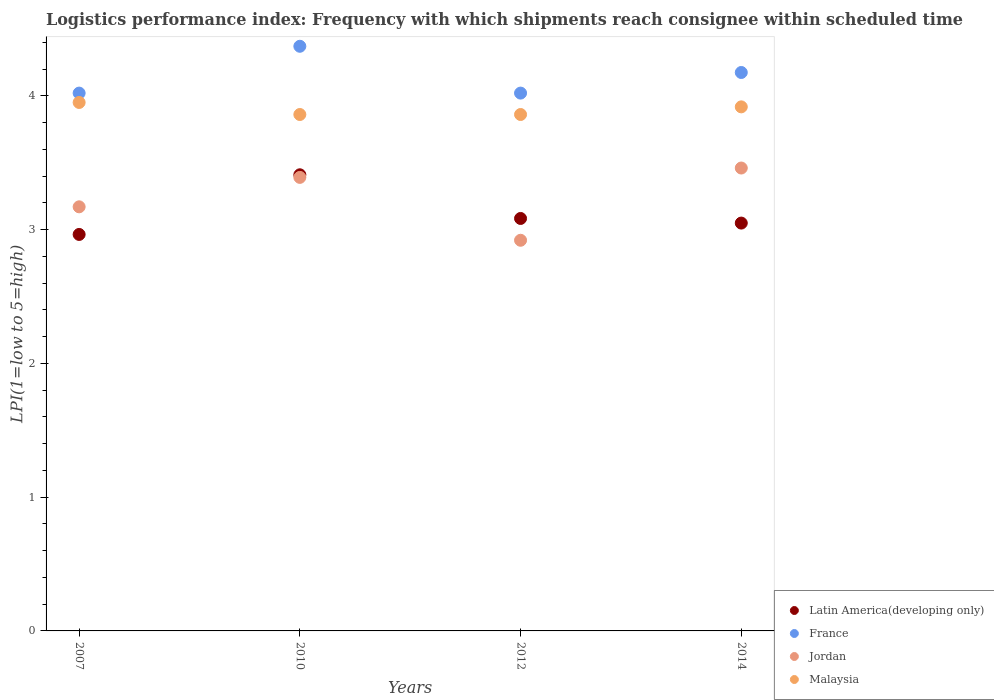How many different coloured dotlines are there?
Your response must be concise. 4. Is the number of dotlines equal to the number of legend labels?
Make the answer very short. Yes. What is the logistics performance index in Latin America(developing only) in 2007?
Provide a short and direct response. 2.96. Across all years, what is the maximum logistics performance index in Latin America(developing only)?
Offer a terse response. 3.41. Across all years, what is the minimum logistics performance index in Latin America(developing only)?
Your answer should be very brief. 2.96. What is the total logistics performance index in France in the graph?
Offer a very short reply. 16.58. What is the difference between the logistics performance index in Latin America(developing only) in 2014 and the logistics performance index in Malaysia in 2010?
Your answer should be compact. -0.81. What is the average logistics performance index in Latin America(developing only) per year?
Provide a short and direct response. 3.13. In the year 2014, what is the difference between the logistics performance index in Latin America(developing only) and logistics performance index in Malaysia?
Your answer should be very brief. -0.87. In how many years, is the logistics performance index in Latin America(developing only) greater than 1.6?
Your response must be concise. 4. What is the ratio of the logistics performance index in France in 2010 to that in 2012?
Ensure brevity in your answer.  1.09. Is the logistics performance index in Malaysia in 2010 less than that in 2012?
Offer a very short reply. No. Is the difference between the logistics performance index in Latin America(developing only) in 2007 and 2010 greater than the difference between the logistics performance index in Malaysia in 2007 and 2010?
Your answer should be compact. No. What is the difference between the highest and the second highest logistics performance index in Jordan?
Offer a very short reply. 0.07. What is the difference between the highest and the lowest logistics performance index in Latin America(developing only)?
Provide a short and direct response. 0.45. In how many years, is the logistics performance index in Malaysia greater than the average logistics performance index in Malaysia taken over all years?
Ensure brevity in your answer.  2. Is it the case that in every year, the sum of the logistics performance index in Malaysia and logistics performance index in Latin America(developing only)  is greater than the logistics performance index in Jordan?
Your answer should be very brief. Yes. Is the logistics performance index in France strictly greater than the logistics performance index in Latin America(developing only) over the years?
Give a very brief answer. Yes. How many dotlines are there?
Keep it short and to the point. 4. Are the values on the major ticks of Y-axis written in scientific E-notation?
Your answer should be very brief. No. Does the graph contain any zero values?
Make the answer very short. No. Where does the legend appear in the graph?
Offer a terse response. Bottom right. How many legend labels are there?
Ensure brevity in your answer.  4. What is the title of the graph?
Give a very brief answer. Logistics performance index: Frequency with which shipments reach consignee within scheduled time. What is the label or title of the Y-axis?
Give a very brief answer. LPI(1=low to 5=high). What is the LPI(1=low to 5=high) in Latin America(developing only) in 2007?
Your answer should be compact. 2.96. What is the LPI(1=low to 5=high) in France in 2007?
Your answer should be very brief. 4.02. What is the LPI(1=low to 5=high) of Jordan in 2007?
Keep it short and to the point. 3.17. What is the LPI(1=low to 5=high) in Malaysia in 2007?
Give a very brief answer. 3.95. What is the LPI(1=low to 5=high) in Latin America(developing only) in 2010?
Make the answer very short. 3.41. What is the LPI(1=low to 5=high) in France in 2010?
Your response must be concise. 4.37. What is the LPI(1=low to 5=high) of Jordan in 2010?
Give a very brief answer. 3.39. What is the LPI(1=low to 5=high) of Malaysia in 2010?
Keep it short and to the point. 3.86. What is the LPI(1=low to 5=high) of Latin America(developing only) in 2012?
Make the answer very short. 3.08. What is the LPI(1=low to 5=high) of France in 2012?
Keep it short and to the point. 4.02. What is the LPI(1=low to 5=high) of Jordan in 2012?
Make the answer very short. 2.92. What is the LPI(1=low to 5=high) of Malaysia in 2012?
Provide a short and direct response. 3.86. What is the LPI(1=low to 5=high) in Latin America(developing only) in 2014?
Ensure brevity in your answer.  3.05. What is the LPI(1=low to 5=high) of France in 2014?
Your answer should be very brief. 4.17. What is the LPI(1=low to 5=high) of Jordan in 2014?
Give a very brief answer. 3.46. What is the LPI(1=low to 5=high) of Malaysia in 2014?
Give a very brief answer. 3.92. Across all years, what is the maximum LPI(1=low to 5=high) of Latin America(developing only)?
Your response must be concise. 3.41. Across all years, what is the maximum LPI(1=low to 5=high) of France?
Provide a short and direct response. 4.37. Across all years, what is the maximum LPI(1=low to 5=high) in Jordan?
Your answer should be very brief. 3.46. Across all years, what is the maximum LPI(1=low to 5=high) of Malaysia?
Your answer should be very brief. 3.95. Across all years, what is the minimum LPI(1=low to 5=high) of Latin America(developing only)?
Give a very brief answer. 2.96. Across all years, what is the minimum LPI(1=low to 5=high) in France?
Your answer should be very brief. 4.02. Across all years, what is the minimum LPI(1=low to 5=high) of Jordan?
Your answer should be compact. 2.92. Across all years, what is the minimum LPI(1=low to 5=high) in Malaysia?
Your answer should be very brief. 3.86. What is the total LPI(1=low to 5=high) of Latin America(developing only) in the graph?
Offer a terse response. 12.5. What is the total LPI(1=low to 5=high) in France in the graph?
Make the answer very short. 16.58. What is the total LPI(1=low to 5=high) of Jordan in the graph?
Your answer should be compact. 12.94. What is the total LPI(1=low to 5=high) of Malaysia in the graph?
Your response must be concise. 15.59. What is the difference between the LPI(1=low to 5=high) in Latin America(developing only) in 2007 and that in 2010?
Make the answer very short. -0.45. What is the difference between the LPI(1=low to 5=high) in France in 2007 and that in 2010?
Ensure brevity in your answer.  -0.35. What is the difference between the LPI(1=low to 5=high) in Jordan in 2007 and that in 2010?
Give a very brief answer. -0.22. What is the difference between the LPI(1=low to 5=high) of Malaysia in 2007 and that in 2010?
Make the answer very short. 0.09. What is the difference between the LPI(1=low to 5=high) of Latin America(developing only) in 2007 and that in 2012?
Your answer should be very brief. -0.12. What is the difference between the LPI(1=low to 5=high) of France in 2007 and that in 2012?
Provide a short and direct response. 0. What is the difference between the LPI(1=low to 5=high) of Jordan in 2007 and that in 2012?
Keep it short and to the point. 0.25. What is the difference between the LPI(1=low to 5=high) in Malaysia in 2007 and that in 2012?
Provide a short and direct response. 0.09. What is the difference between the LPI(1=low to 5=high) of Latin America(developing only) in 2007 and that in 2014?
Make the answer very short. -0.08. What is the difference between the LPI(1=low to 5=high) of France in 2007 and that in 2014?
Give a very brief answer. -0.15. What is the difference between the LPI(1=low to 5=high) in Jordan in 2007 and that in 2014?
Keep it short and to the point. -0.29. What is the difference between the LPI(1=low to 5=high) of Malaysia in 2007 and that in 2014?
Make the answer very short. 0.03. What is the difference between the LPI(1=low to 5=high) of Latin America(developing only) in 2010 and that in 2012?
Ensure brevity in your answer.  0.33. What is the difference between the LPI(1=low to 5=high) of Jordan in 2010 and that in 2012?
Give a very brief answer. 0.47. What is the difference between the LPI(1=low to 5=high) of Malaysia in 2010 and that in 2012?
Your answer should be very brief. 0. What is the difference between the LPI(1=low to 5=high) in Latin America(developing only) in 2010 and that in 2014?
Ensure brevity in your answer.  0.36. What is the difference between the LPI(1=low to 5=high) of France in 2010 and that in 2014?
Ensure brevity in your answer.  0.2. What is the difference between the LPI(1=low to 5=high) in Jordan in 2010 and that in 2014?
Provide a short and direct response. -0.07. What is the difference between the LPI(1=low to 5=high) in Malaysia in 2010 and that in 2014?
Your answer should be very brief. -0.06. What is the difference between the LPI(1=low to 5=high) of Latin America(developing only) in 2012 and that in 2014?
Provide a short and direct response. 0.03. What is the difference between the LPI(1=low to 5=high) in France in 2012 and that in 2014?
Your answer should be very brief. -0.15. What is the difference between the LPI(1=low to 5=high) of Jordan in 2012 and that in 2014?
Offer a terse response. -0.54. What is the difference between the LPI(1=low to 5=high) of Malaysia in 2012 and that in 2014?
Your answer should be very brief. -0.06. What is the difference between the LPI(1=low to 5=high) of Latin America(developing only) in 2007 and the LPI(1=low to 5=high) of France in 2010?
Your answer should be very brief. -1.41. What is the difference between the LPI(1=low to 5=high) of Latin America(developing only) in 2007 and the LPI(1=low to 5=high) of Jordan in 2010?
Keep it short and to the point. -0.43. What is the difference between the LPI(1=low to 5=high) of Latin America(developing only) in 2007 and the LPI(1=low to 5=high) of Malaysia in 2010?
Your answer should be compact. -0.9. What is the difference between the LPI(1=low to 5=high) of France in 2007 and the LPI(1=low to 5=high) of Jordan in 2010?
Make the answer very short. 0.63. What is the difference between the LPI(1=low to 5=high) in France in 2007 and the LPI(1=low to 5=high) in Malaysia in 2010?
Keep it short and to the point. 0.16. What is the difference between the LPI(1=low to 5=high) in Jordan in 2007 and the LPI(1=low to 5=high) in Malaysia in 2010?
Your answer should be compact. -0.69. What is the difference between the LPI(1=low to 5=high) in Latin America(developing only) in 2007 and the LPI(1=low to 5=high) in France in 2012?
Provide a succinct answer. -1.06. What is the difference between the LPI(1=low to 5=high) of Latin America(developing only) in 2007 and the LPI(1=low to 5=high) of Jordan in 2012?
Provide a succinct answer. 0.04. What is the difference between the LPI(1=low to 5=high) of Latin America(developing only) in 2007 and the LPI(1=low to 5=high) of Malaysia in 2012?
Provide a succinct answer. -0.9. What is the difference between the LPI(1=low to 5=high) of France in 2007 and the LPI(1=low to 5=high) of Jordan in 2012?
Ensure brevity in your answer.  1.1. What is the difference between the LPI(1=low to 5=high) of France in 2007 and the LPI(1=low to 5=high) of Malaysia in 2012?
Your answer should be compact. 0.16. What is the difference between the LPI(1=low to 5=high) of Jordan in 2007 and the LPI(1=low to 5=high) of Malaysia in 2012?
Your answer should be compact. -0.69. What is the difference between the LPI(1=low to 5=high) in Latin America(developing only) in 2007 and the LPI(1=low to 5=high) in France in 2014?
Your response must be concise. -1.21. What is the difference between the LPI(1=low to 5=high) in Latin America(developing only) in 2007 and the LPI(1=low to 5=high) in Jordan in 2014?
Make the answer very short. -0.5. What is the difference between the LPI(1=low to 5=high) in Latin America(developing only) in 2007 and the LPI(1=low to 5=high) in Malaysia in 2014?
Ensure brevity in your answer.  -0.95. What is the difference between the LPI(1=low to 5=high) of France in 2007 and the LPI(1=low to 5=high) of Jordan in 2014?
Your answer should be compact. 0.56. What is the difference between the LPI(1=low to 5=high) in France in 2007 and the LPI(1=low to 5=high) in Malaysia in 2014?
Offer a very short reply. 0.1. What is the difference between the LPI(1=low to 5=high) in Jordan in 2007 and the LPI(1=low to 5=high) in Malaysia in 2014?
Your answer should be compact. -0.75. What is the difference between the LPI(1=low to 5=high) in Latin America(developing only) in 2010 and the LPI(1=low to 5=high) in France in 2012?
Provide a succinct answer. -0.61. What is the difference between the LPI(1=low to 5=high) in Latin America(developing only) in 2010 and the LPI(1=low to 5=high) in Jordan in 2012?
Give a very brief answer. 0.49. What is the difference between the LPI(1=low to 5=high) of Latin America(developing only) in 2010 and the LPI(1=low to 5=high) of Malaysia in 2012?
Give a very brief answer. -0.45. What is the difference between the LPI(1=low to 5=high) of France in 2010 and the LPI(1=low to 5=high) of Jordan in 2012?
Provide a short and direct response. 1.45. What is the difference between the LPI(1=low to 5=high) in France in 2010 and the LPI(1=low to 5=high) in Malaysia in 2012?
Your answer should be compact. 0.51. What is the difference between the LPI(1=low to 5=high) in Jordan in 2010 and the LPI(1=low to 5=high) in Malaysia in 2012?
Keep it short and to the point. -0.47. What is the difference between the LPI(1=low to 5=high) in Latin America(developing only) in 2010 and the LPI(1=low to 5=high) in France in 2014?
Offer a terse response. -0.76. What is the difference between the LPI(1=low to 5=high) in Latin America(developing only) in 2010 and the LPI(1=low to 5=high) in Jordan in 2014?
Provide a short and direct response. -0.05. What is the difference between the LPI(1=low to 5=high) of Latin America(developing only) in 2010 and the LPI(1=low to 5=high) of Malaysia in 2014?
Make the answer very short. -0.51. What is the difference between the LPI(1=low to 5=high) in France in 2010 and the LPI(1=low to 5=high) in Jordan in 2014?
Keep it short and to the point. 0.91. What is the difference between the LPI(1=low to 5=high) in France in 2010 and the LPI(1=low to 5=high) in Malaysia in 2014?
Your answer should be very brief. 0.45. What is the difference between the LPI(1=low to 5=high) of Jordan in 2010 and the LPI(1=low to 5=high) of Malaysia in 2014?
Offer a terse response. -0.53. What is the difference between the LPI(1=low to 5=high) in Latin America(developing only) in 2012 and the LPI(1=low to 5=high) in France in 2014?
Give a very brief answer. -1.09. What is the difference between the LPI(1=low to 5=high) in Latin America(developing only) in 2012 and the LPI(1=low to 5=high) in Jordan in 2014?
Make the answer very short. -0.38. What is the difference between the LPI(1=low to 5=high) in Latin America(developing only) in 2012 and the LPI(1=low to 5=high) in Malaysia in 2014?
Offer a very short reply. -0.83. What is the difference between the LPI(1=low to 5=high) in France in 2012 and the LPI(1=low to 5=high) in Jordan in 2014?
Offer a terse response. 0.56. What is the difference between the LPI(1=low to 5=high) of France in 2012 and the LPI(1=low to 5=high) of Malaysia in 2014?
Your answer should be compact. 0.1. What is the difference between the LPI(1=low to 5=high) in Jordan in 2012 and the LPI(1=low to 5=high) in Malaysia in 2014?
Offer a very short reply. -1. What is the average LPI(1=low to 5=high) in Latin America(developing only) per year?
Offer a very short reply. 3.13. What is the average LPI(1=low to 5=high) in France per year?
Provide a succinct answer. 4.15. What is the average LPI(1=low to 5=high) of Jordan per year?
Provide a succinct answer. 3.23. What is the average LPI(1=low to 5=high) in Malaysia per year?
Provide a succinct answer. 3.9. In the year 2007, what is the difference between the LPI(1=low to 5=high) in Latin America(developing only) and LPI(1=low to 5=high) in France?
Keep it short and to the point. -1.06. In the year 2007, what is the difference between the LPI(1=low to 5=high) of Latin America(developing only) and LPI(1=low to 5=high) of Jordan?
Give a very brief answer. -0.21. In the year 2007, what is the difference between the LPI(1=low to 5=high) of Latin America(developing only) and LPI(1=low to 5=high) of Malaysia?
Give a very brief answer. -0.99. In the year 2007, what is the difference between the LPI(1=low to 5=high) of France and LPI(1=low to 5=high) of Jordan?
Provide a succinct answer. 0.85. In the year 2007, what is the difference between the LPI(1=low to 5=high) in France and LPI(1=low to 5=high) in Malaysia?
Your answer should be very brief. 0.07. In the year 2007, what is the difference between the LPI(1=low to 5=high) in Jordan and LPI(1=low to 5=high) in Malaysia?
Provide a succinct answer. -0.78. In the year 2010, what is the difference between the LPI(1=low to 5=high) of Latin America(developing only) and LPI(1=low to 5=high) of France?
Give a very brief answer. -0.96. In the year 2010, what is the difference between the LPI(1=low to 5=high) in Latin America(developing only) and LPI(1=low to 5=high) in Jordan?
Your answer should be compact. 0.02. In the year 2010, what is the difference between the LPI(1=low to 5=high) of Latin America(developing only) and LPI(1=low to 5=high) of Malaysia?
Your response must be concise. -0.45. In the year 2010, what is the difference between the LPI(1=low to 5=high) in France and LPI(1=low to 5=high) in Malaysia?
Offer a terse response. 0.51. In the year 2010, what is the difference between the LPI(1=low to 5=high) of Jordan and LPI(1=low to 5=high) of Malaysia?
Offer a very short reply. -0.47. In the year 2012, what is the difference between the LPI(1=low to 5=high) in Latin America(developing only) and LPI(1=low to 5=high) in France?
Your answer should be very brief. -0.94. In the year 2012, what is the difference between the LPI(1=low to 5=high) in Latin America(developing only) and LPI(1=low to 5=high) in Jordan?
Ensure brevity in your answer.  0.16. In the year 2012, what is the difference between the LPI(1=low to 5=high) in Latin America(developing only) and LPI(1=low to 5=high) in Malaysia?
Give a very brief answer. -0.78. In the year 2012, what is the difference between the LPI(1=low to 5=high) in France and LPI(1=low to 5=high) in Malaysia?
Your answer should be very brief. 0.16. In the year 2012, what is the difference between the LPI(1=low to 5=high) in Jordan and LPI(1=low to 5=high) in Malaysia?
Give a very brief answer. -0.94. In the year 2014, what is the difference between the LPI(1=low to 5=high) of Latin America(developing only) and LPI(1=low to 5=high) of France?
Provide a succinct answer. -1.13. In the year 2014, what is the difference between the LPI(1=low to 5=high) in Latin America(developing only) and LPI(1=low to 5=high) in Jordan?
Provide a short and direct response. -0.41. In the year 2014, what is the difference between the LPI(1=low to 5=high) of Latin America(developing only) and LPI(1=low to 5=high) of Malaysia?
Your response must be concise. -0.87. In the year 2014, what is the difference between the LPI(1=low to 5=high) in France and LPI(1=low to 5=high) in Jordan?
Give a very brief answer. 0.71. In the year 2014, what is the difference between the LPI(1=low to 5=high) of France and LPI(1=low to 5=high) of Malaysia?
Your answer should be compact. 0.26. In the year 2014, what is the difference between the LPI(1=low to 5=high) in Jordan and LPI(1=low to 5=high) in Malaysia?
Ensure brevity in your answer.  -0.46. What is the ratio of the LPI(1=low to 5=high) of Latin America(developing only) in 2007 to that in 2010?
Your response must be concise. 0.87. What is the ratio of the LPI(1=low to 5=high) of France in 2007 to that in 2010?
Your answer should be very brief. 0.92. What is the ratio of the LPI(1=low to 5=high) in Jordan in 2007 to that in 2010?
Your answer should be very brief. 0.94. What is the ratio of the LPI(1=low to 5=high) in Malaysia in 2007 to that in 2010?
Your response must be concise. 1.02. What is the ratio of the LPI(1=low to 5=high) of Latin America(developing only) in 2007 to that in 2012?
Make the answer very short. 0.96. What is the ratio of the LPI(1=low to 5=high) in France in 2007 to that in 2012?
Provide a succinct answer. 1. What is the ratio of the LPI(1=low to 5=high) of Jordan in 2007 to that in 2012?
Provide a short and direct response. 1.09. What is the ratio of the LPI(1=low to 5=high) in Malaysia in 2007 to that in 2012?
Give a very brief answer. 1.02. What is the ratio of the LPI(1=low to 5=high) in Latin America(developing only) in 2007 to that in 2014?
Your answer should be compact. 0.97. What is the ratio of the LPI(1=low to 5=high) in France in 2007 to that in 2014?
Make the answer very short. 0.96. What is the ratio of the LPI(1=low to 5=high) in Jordan in 2007 to that in 2014?
Your response must be concise. 0.92. What is the ratio of the LPI(1=low to 5=high) in Malaysia in 2007 to that in 2014?
Your answer should be compact. 1.01. What is the ratio of the LPI(1=low to 5=high) in Latin America(developing only) in 2010 to that in 2012?
Offer a very short reply. 1.11. What is the ratio of the LPI(1=low to 5=high) in France in 2010 to that in 2012?
Offer a terse response. 1.09. What is the ratio of the LPI(1=low to 5=high) in Jordan in 2010 to that in 2012?
Make the answer very short. 1.16. What is the ratio of the LPI(1=low to 5=high) in Malaysia in 2010 to that in 2012?
Your response must be concise. 1. What is the ratio of the LPI(1=low to 5=high) in Latin America(developing only) in 2010 to that in 2014?
Make the answer very short. 1.12. What is the ratio of the LPI(1=low to 5=high) of France in 2010 to that in 2014?
Provide a succinct answer. 1.05. What is the ratio of the LPI(1=low to 5=high) in Jordan in 2010 to that in 2014?
Offer a terse response. 0.98. What is the ratio of the LPI(1=low to 5=high) in Malaysia in 2010 to that in 2014?
Your response must be concise. 0.99. What is the ratio of the LPI(1=low to 5=high) in Latin America(developing only) in 2012 to that in 2014?
Offer a terse response. 1.01. What is the ratio of the LPI(1=low to 5=high) in France in 2012 to that in 2014?
Your answer should be compact. 0.96. What is the ratio of the LPI(1=low to 5=high) of Jordan in 2012 to that in 2014?
Give a very brief answer. 0.84. What is the ratio of the LPI(1=low to 5=high) in Malaysia in 2012 to that in 2014?
Your answer should be very brief. 0.99. What is the difference between the highest and the second highest LPI(1=low to 5=high) in Latin America(developing only)?
Ensure brevity in your answer.  0.33. What is the difference between the highest and the second highest LPI(1=low to 5=high) of France?
Your answer should be very brief. 0.2. What is the difference between the highest and the second highest LPI(1=low to 5=high) of Jordan?
Provide a succinct answer. 0.07. What is the difference between the highest and the second highest LPI(1=low to 5=high) in Malaysia?
Your response must be concise. 0.03. What is the difference between the highest and the lowest LPI(1=low to 5=high) of Latin America(developing only)?
Your response must be concise. 0.45. What is the difference between the highest and the lowest LPI(1=low to 5=high) of Jordan?
Your response must be concise. 0.54. What is the difference between the highest and the lowest LPI(1=low to 5=high) in Malaysia?
Keep it short and to the point. 0.09. 